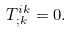Convert formula to latex. <formula><loc_0><loc_0><loc_500><loc_500>T ^ { i k } _ { ; k } = 0 .</formula> 